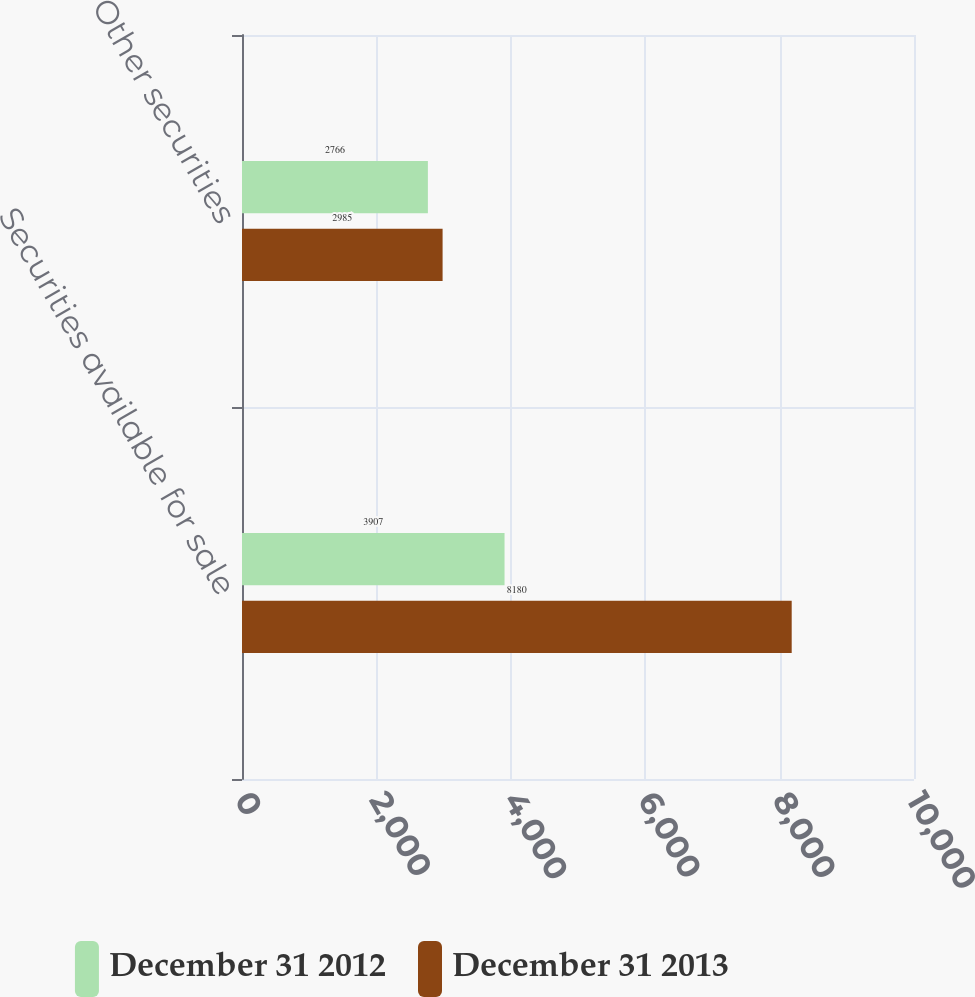Convert chart to OTSL. <chart><loc_0><loc_0><loc_500><loc_500><stacked_bar_chart><ecel><fcel>Securities available for sale<fcel>Other securities<nl><fcel>December 31 2012<fcel>3907<fcel>2766<nl><fcel>December 31 2013<fcel>8180<fcel>2985<nl></chart> 